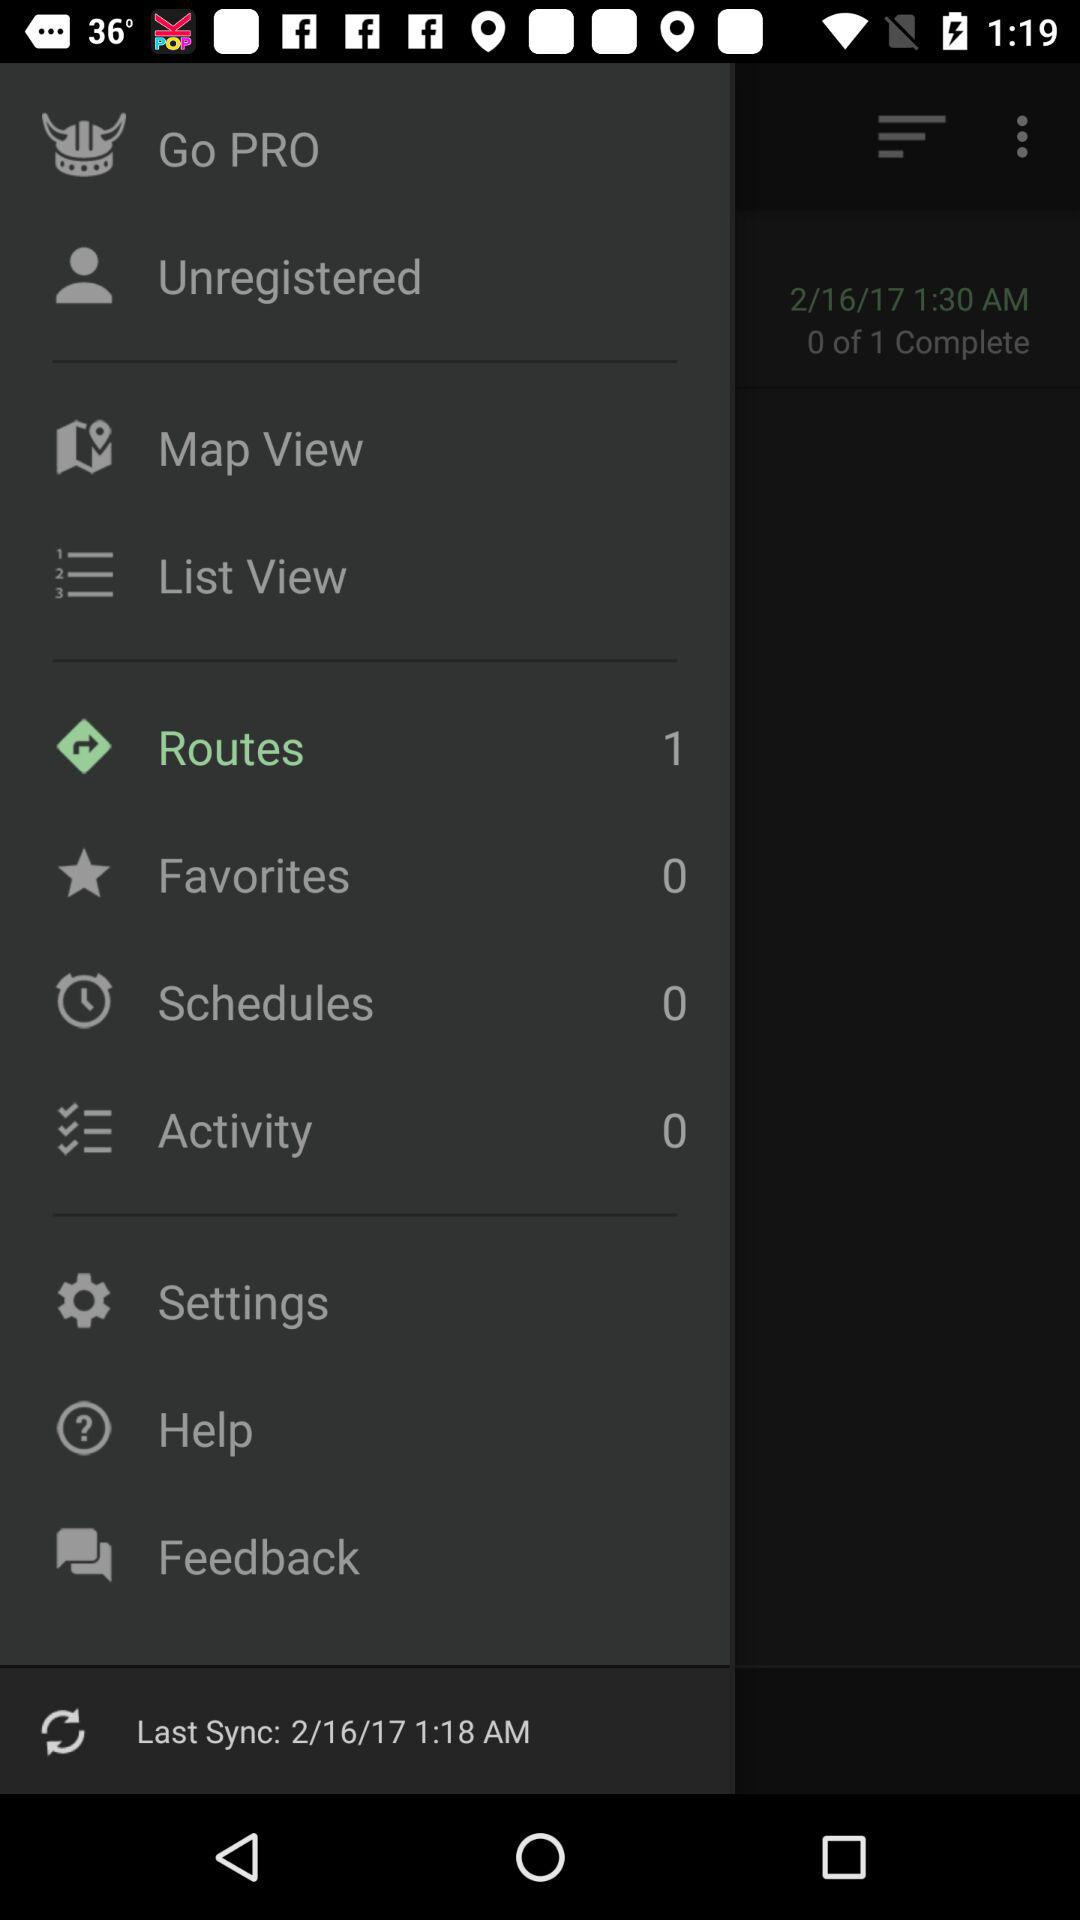How many routes are there? There is 1 route. 